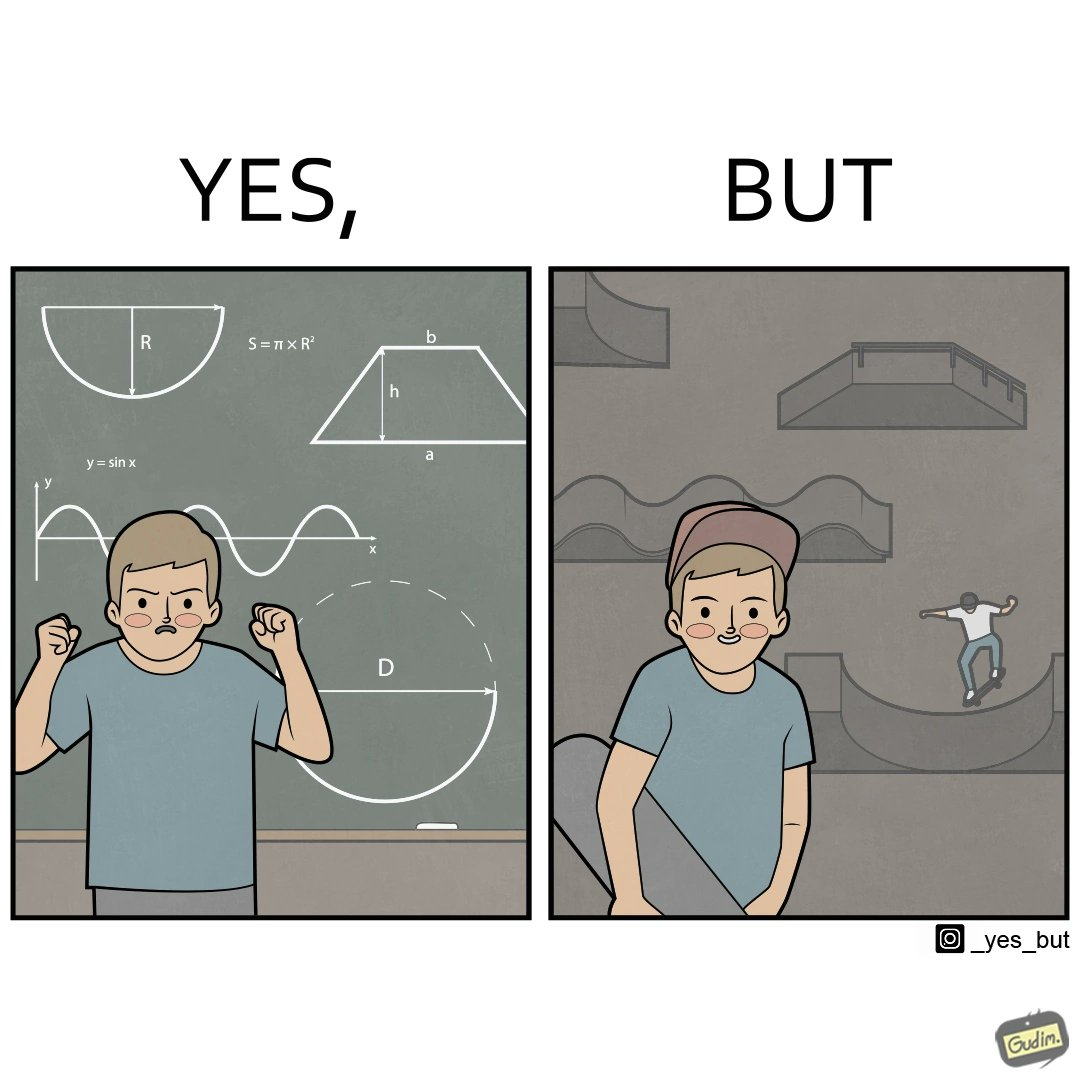What is shown in the left half versus the right half of this image? In the left part of the image: The image shows a boy annoyed with studying maths. Behind him is a board with lots of shapes like  semi-circle and trapezoid drawn along with mathematical formulas like areas of circle. There is a graph of sinusodial curve also drawn on the board. In the right part of the image: The image shows a boy wearing a cap with a skateboard in his hands. He is happy. In his background there is a skateboard park. In the background there is a person skateboarding on a semi cirular bowl. We also see bowls of other shapes like trapezoid and sine wave. 